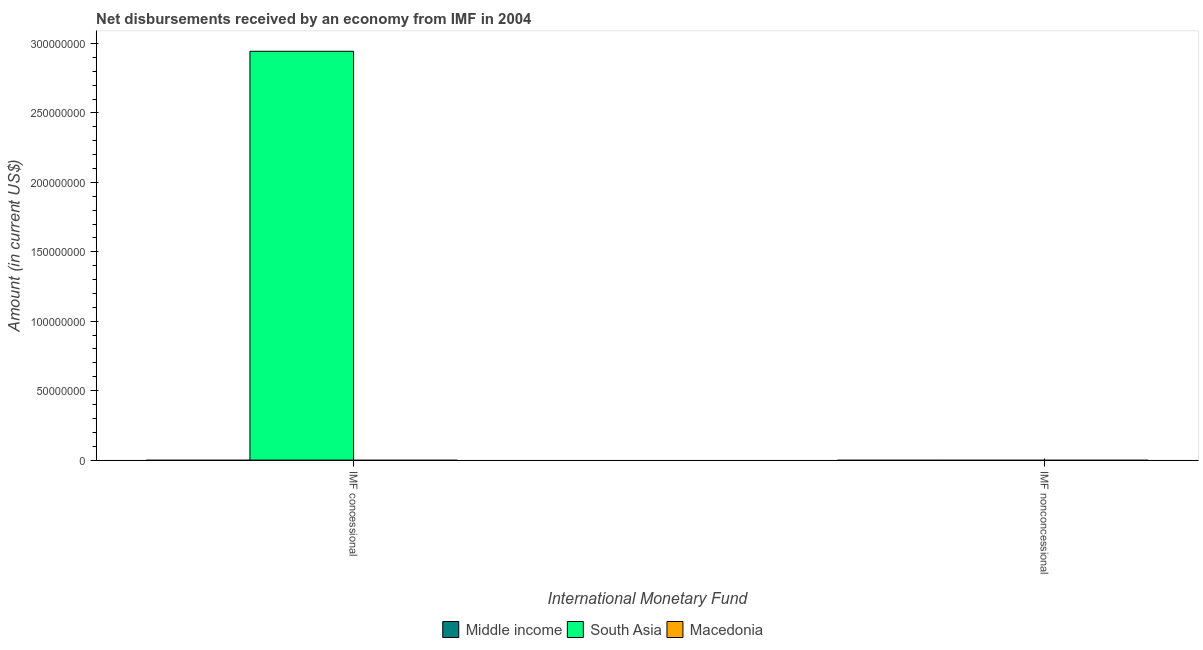How many different coloured bars are there?
Offer a terse response. 1. Are the number of bars on each tick of the X-axis equal?
Provide a succinct answer. No. What is the label of the 2nd group of bars from the left?
Offer a terse response. IMF nonconcessional. Across all countries, what is the maximum net concessional disbursements from imf?
Your answer should be compact. 2.94e+08. Across all countries, what is the minimum net concessional disbursements from imf?
Keep it short and to the point. 0. In which country was the net concessional disbursements from imf maximum?
Make the answer very short. South Asia. What is the total net non concessional disbursements from imf in the graph?
Ensure brevity in your answer.  0. In how many countries, is the net non concessional disbursements from imf greater than 200000000 US$?
Keep it short and to the point. 0. In how many countries, is the net non concessional disbursements from imf greater than the average net non concessional disbursements from imf taken over all countries?
Your answer should be very brief. 0. How many bars are there?
Keep it short and to the point. 1. How many countries are there in the graph?
Offer a terse response. 3. What is the difference between two consecutive major ticks on the Y-axis?
Your answer should be compact. 5.00e+07. Does the graph contain any zero values?
Provide a succinct answer. Yes. How are the legend labels stacked?
Your response must be concise. Horizontal. What is the title of the graph?
Offer a very short reply. Net disbursements received by an economy from IMF in 2004. Does "Moldova" appear as one of the legend labels in the graph?
Your response must be concise. No. What is the label or title of the X-axis?
Keep it short and to the point. International Monetary Fund. What is the label or title of the Y-axis?
Offer a terse response. Amount (in current US$). What is the Amount (in current US$) of Middle income in IMF concessional?
Your answer should be very brief. 0. What is the Amount (in current US$) in South Asia in IMF concessional?
Ensure brevity in your answer.  2.94e+08. What is the Amount (in current US$) in South Asia in IMF nonconcessional?
Keep it short and to the point. 0. What is the Amount (in current US$) of Macedonia in IMF nonconcessional?
Provide a short and direct response. 0. Across all International Monetary Fund, what is the maximum Amount (in current US$) in South Asia?
Your answer should be compact. 2.94e+08. Across all International Monetary Fund, what is the minimum Amount (in current US$) of South Asia?
Provide a short and direct response. 0. What is the total Amount (in current US$) of Middle income in the graph?
Give a very brief answer. 0. What is the total Amount (in current US$) in South Asia in the graph?
Provide a short and direct response. 2.94e+08. What is the total Amount (in current US$) in Macedonia in the graph?
Ensure brevity in your answer.  0. What is the average Amount (in current US$) in South Asia per International Monetary Fund?
Ensure brevity in your answer.  1.47e+08. What is the difference between the highest and the lowest Amount (in current US$) in South Asia?
Ensure brevity in your answer.  2.94e+08. 